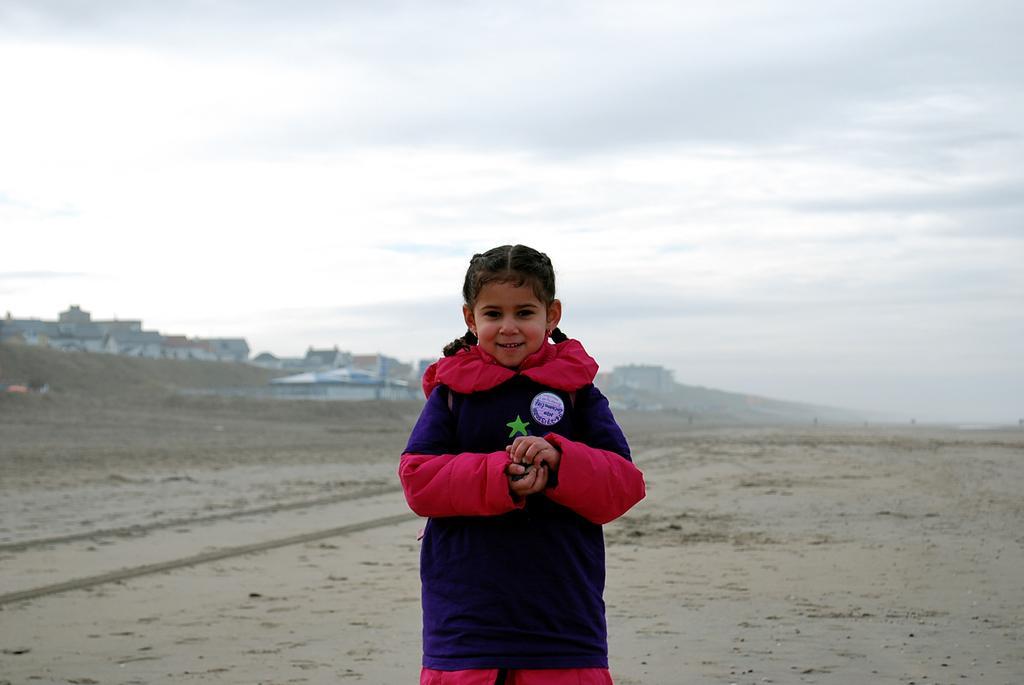Could you give a brief overview of what you see in this image? In this picture we can see a kid is standing and smiling, at the bottom there is soil, in the background we can see buildings, there is the sky at the top of the picture. 